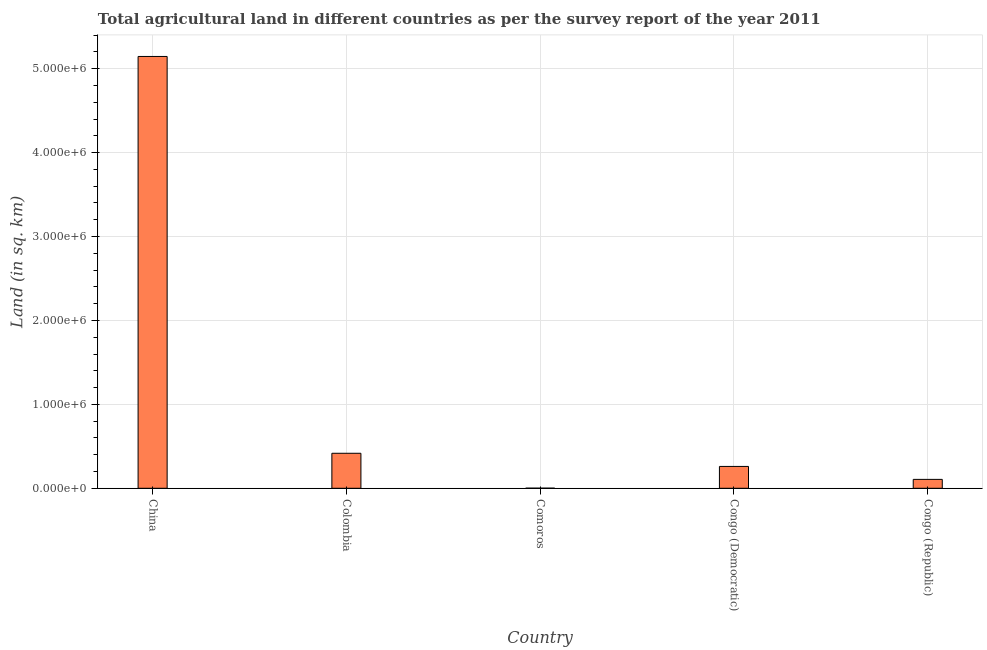What is the title of the graph?
Your answer should be very brief. Total agricultural land in different countries as per the survey report of the year 2011. What is the label or title of the X-axis?
Your answer should be very brief. Country. What is the label or title of the Y-axis?
Provide a short and direct response. Land (in sq. km). What is the agricultural land in Colombia?
Ensure brevity in your answer.  4.17e+05. Across all countries, what is the maximum agricultural land?
Keep it short and to the point. 5.15e+06. Across all countries, what is the minimum agricultural land?
Provide a short and direct response. 1330. In which country was the agricultural land maximum?
Give a very brief answer. China. In which country was the agricultural land minimum?
Your answer should be compact. Comoros. What is the sum of the agricultural land?
Provide a short and direct response. 5.93e+06. What is the difference between the agricultural land in Congo (Democratic) and Congo (Republic)?
Offer a very short reply. 1.54e+05. What is the average agricultural land per country?
Make the answer very short. 1.19e+06. What is the median agricultural land?
Ensure brevity in your answer.  2.60e+05. In how many countries, is the agricultural land greater than 800000 sq. km?
Provide a short and direct response. 1. What is the ratio of the agricultural land in China to that in Congo (Democratic)?
Your answer should be compact. 19.76. Is the agricultural land in Colombia less than that in Comoros?
Ensure brevity in your answer.  No. What is the difference between the highest and the second highest agricultural land?
Give a very brief answer. 4.73e+06. What is the difference between the highest and the lowest agricultural land?
Offer a very short reply. 5.14e+06. How many countries are there in the graph?
Your response must be concise. 5. What is the difference between two consecutive major ticks on the Y-axis?
Provide a short and direct response. 1.00e+06. Are the values on the major ticks of Y-axis written in scientific E-notation?
Give a very brief answer. Yes. What is the Land (in sq. km) in China?
Make the answer very short. 5.15e+06. What is the Land (in sq. km) in Colombia?
Provide a short and direct response. 4.17e+05. What is the Land (in sq. km) in Comoros?
Provide a succinct answer. 1330. What is the Land (in sq. km) of Congo (Democratic)?
Your answer should be compact. 2.60e+05. What is the Land (in sq. km) of Congo (Republic)?
Make the answer very short. 1.06e+05. What is the difference between the Land (in sq. km) in China and Colombia?
Provide a short and direct response. 4.73e+06. What is the difference between the Land (in sq. km) in China and Comoros?
Your response must be concise. 5.14e+06. What is the difference between the Land (in sq. km) in China and Congo (Democratic)?
Provide a short and direct response. 4.89e+06. What is the difference between the Land (in sq. km) in China and Congo (Republic)?
Your response must be concise. 5.04e+06. What is the difference between the Land (in sq. km) in Colombia and Comoros?
Make the answer very short. 4.16e+05. What is the difference between the Land (in sq. km) in Colombia and Congo (Democratic)?
Your answer should be very brief. 1.57e+05. What is the difference between the Land (in sq. km) in Colombia and Congo (Republic)?
Provide a succinct answer. 3.11e+05. What is the difference between the Land (in sq. km) in Comoros and Congo (Democratic)?
Your answer should be compact. -2.59e+05. What is the difference between the Land (in sq. km) in Comoros and Congo (Republic)?
Ensure brevity in your answer.  -1.05e+05. What is the difference between the Land (in sq. km) in Congo (Democratic) and Congo (Republic)?
Offer a very short reply. 1.54e+05. What is the ratio of the Land (in sq. km) in China to that in Colombia?
Make the answer very short. 12.33. What is the ratio of the Land (in sq. km) in China to that in Comoros?
Your response must be concise. 3868.82. What is the ratio of the Land (in sq. km) in China to that in Congo (Democratic)?
Make the answer very short. 19.76. What is the ratio of the Land (in sq. km) in China to that in Congo (Republic)?
Provide a succinct answer. 48.56. What is the ratio of the Land (in sq. km) in Colombia to that in Comoros?
Offer a very short reply. 313.69. What is the ratio of the Land (in sq. km) in Colombia to that in Congo (Democratic)?
Give a very brief answer. 1.6. What is the ratio of the Land (in sq. km) in Colombia to that in Congo (Republic)?
Ensure brevity in your answer.  3.94. What is the ratio of the Land (in sq. km) in Comoros to that in Congo (Democratic)?
Your answer should be very brief. 0.01. What is the ratio of the Land (in sq. km) in Comoros to that in Congo (Republic)?
Make the answer very short. 0.01. What is the ratio of the Land (in sq. km) in Congo (Democratic) to that in Congo (Republic)?
Offer a terse response. 2.46. 